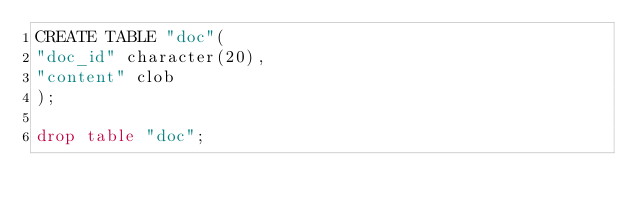Convert code to text. <code><loc_0><loc_0><loc_500><loc_500><_SQL_>CREATE TABLE "doc"( 
"doc_id" character(20), 
"content" clob 
); 

drop table "doc";
</code> 